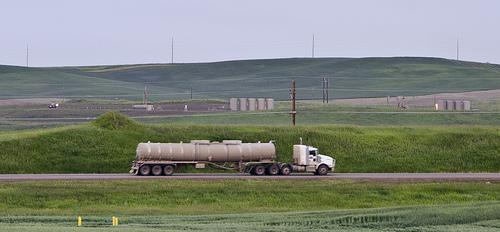How many trucks?
Give a very brief answer. 1. 